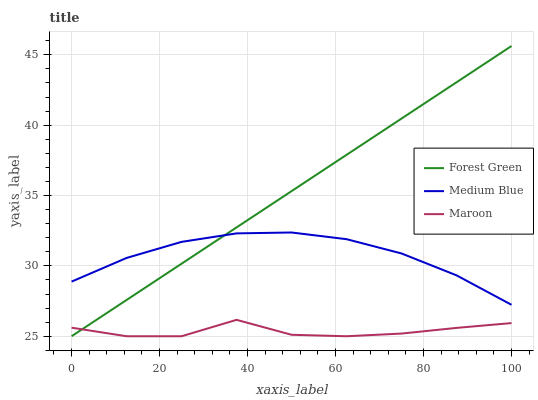Does Maroon have the minimum area under the curve?
Answer yes or no. Yes. Does Forest Green have the maximum area under the curve?
Answer yes or no. Yes. Does Medium Blue have the minimum area under the curve?
Answer yes or no. No. Does Medium Blue have the maximum area under the curve?
Answer yes or no. No. Is Forest Green the smoothest?
Answer yes or no. Yes. Is Maroon the roughest?
Answer yes or no. Yes. Is Medium Blue the smoothest?
Answer yes or no. No. Is Medium Blue the roughest?
Answer yes or no. No. Does Forest Green have the lowest value?
Answer yes or no. Yes. Does Medium Blue have the lowest value?
Answer yes or no. No. Does Forest Green have the highest value?
Answer yes or no. Yes. Does Medium Blue have the highest value?
Answer yes or no. No. Is Maroon less than Medium Blue?
Answer yes or no. Yes. Is Medium Blue greater than Maroon?
Answer yes or no. Yes. Does Forest Green intersect Maroon?
Answer yes or no. Yes. Is Forest Green less than Maroon?
Answer yes or no. No. Is Forest Green greater than Maroon?
Answer yes or no. No. Does Maroon intersect Medium Blue?
Answer yes or no. No. 